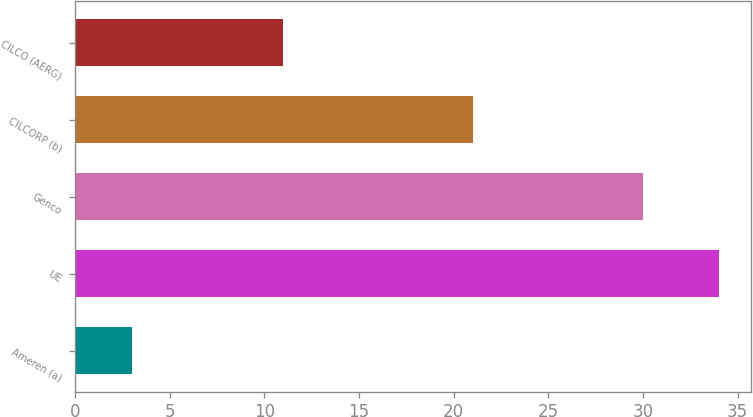<chart> <loc_0><loc_0><loc_500><loc_500><bar_chart><fcel>Ameren (a)<fcel>UE<fcel>Genco<fcel>CILCORP (b)<fcel>CILCO (AERG)<nl><fcel>3<fcel>34<fcel>30<fcel>21<fcel>11<nl></chart> 